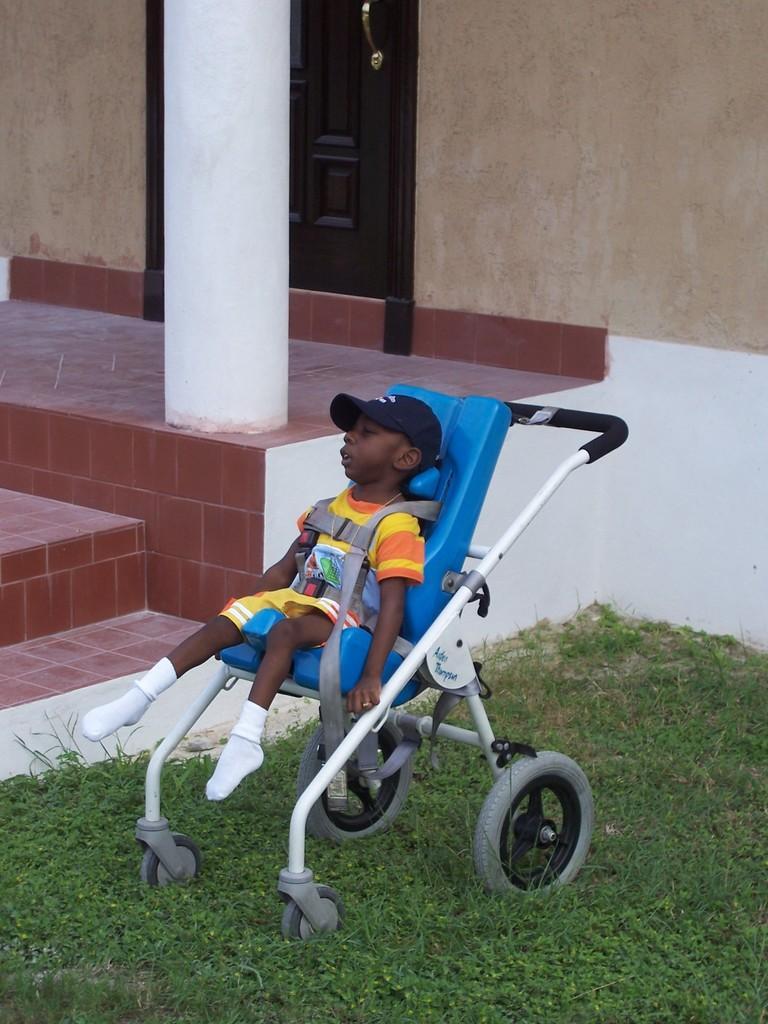Could you give a brief overview of what you see in this image? In this picture I can observe a kid sitting in the stroller. The kid is wearing black color cap on his head. There is some grass on the ground. On the left side I can observe white color pillar. In the background there is a door and wall. 